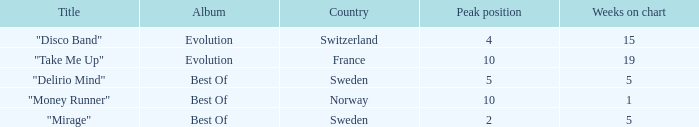What is the title of the single with the peak position of 10 and from France? "Take Me Up". 